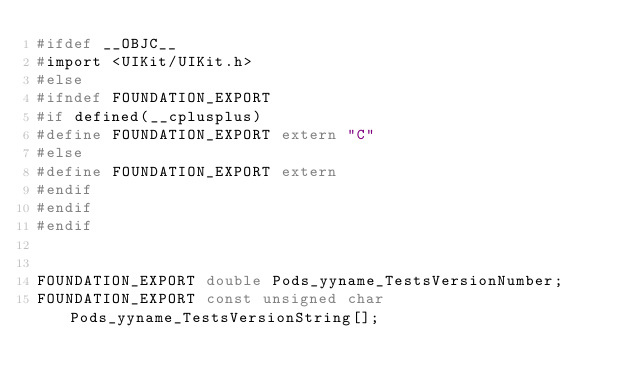<code> <loc_0><loc_0><loc_500><loc_500><_C_>#ifdef __OBJC__
#import <UIKit/UIKit.h>
#else
#ifndef FOUNDATION_EXPORT
#if defined(__cplusplus)
#define FOUNDATION_EXPORT extern "C"
#else
#define FOUNDATION_EXPORT extern
#endif
#endif
#endif


FOUNDATION_EXPORT double Pods_yyname_TestsVersionNumber;
FOUNDATION_EXPORT const unsigned char Pods_yyname_TestsVersionString[];

</code> 